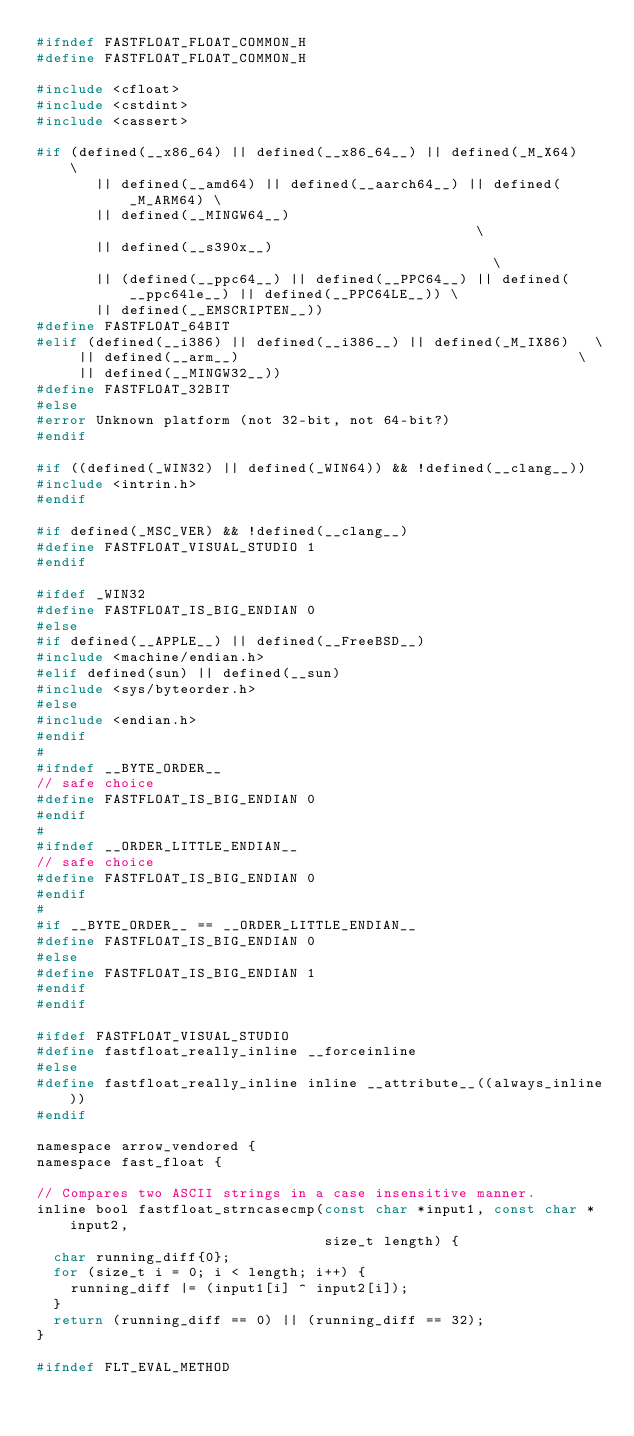<code> <loc_0><loc_0><loc_500><loc_500><_C_>#ifndef FASTFLOAT_FLOAT_COMMON_H
#define FASTFLOAT_FLOAT_COMMON_H

#include <cfloat>
#include <cstdint>
#include <cassert>

#if (defined(__x86_64) || defined(__x86_64__) || defined(_M_X64)   \
       || defined(__amd64) || defined(__aarch64__) || defined(_M_ARM64) \
       || defined(__MINGW64__)                                          \
       || defined(__s390x__)                                            \
       || (defined(__ppc64__) || defined(__PPC64__) || defined(__ppc64le__) || defined(__PPC64LE__)) \
       || defined(__EMSCRIPTEN__))
#define FASTFLOAT_64BIT
#elif (defined(__i386) || defined(__i386__) || defined(_M_IX86)   \
     || defined(__arm__)                                        \
     || defined(__MINGW32__))
#define FASTFLOAT_32BIT
#else
#error Unknown platform (not 32-bit, not 64-bit?)
#endif

#if ((defined(_WIN32) || defined(_WIN64)) && !defined(__clang__))
#include <intrin.h>
#endif

#if defined(_MSC_VER) && !defined(__clang__)
#define FASTFLOAT_VISUAL_STUDIO 1
#endif

#ifdef _WIN32
#define FASTFLOAT_IS_BIG_ENDIAN 0
#else
#if defined(__APPLE__) || defined(__FreeBSD__)
#include <machine/endian.h>
#elif defined(sun) || defined(__sun)
#include <sys/byteorder.h>
#else
#include <endian.h>
#endif
#
#ifndef __BYTE_ORDER__
// safe choice
#define FASTFLOAT_IS_BIG_ENDIAN 0
#endif
#
#ifndef __ORDER_LITTLE_ENDIAN__
// safe choice
#define FASTFLOAT_IS_BIG_ENDIAN 0
#endif
#
#if __BYTE_ORDER__ == __ORDER_LITTLE_ENDIAN__
#define FASTFLOAT_IS_BIG_ENDIAN 0
#else
#define FASTFLOAT_IS_BIG_ENDIAN 1
#endif
#endif

#ifdef FASTFLOAT_VISUAL_STUDIO
#define fastfloat_really_inline __forceinline
#else
#define fastfloat_really_inline inline __attribute__((always_inline))
#endif

namespace arrow_vendored {
namespace fast_float {

// Compares two ASCII strings in a case insensitive manner.
inline bool fastfloat_strncasecmp(const char *input1, const char *input2,
                                  size_t length) {
  char running_diff{0};
  for (size_t i = 0; i < length; i++) {
    running_diff |= (input1[i] ^ input2[i]);
  }
  return (running_diff == 0) || (running_diff == 32);
}

#ifndef FLT_EVAL_METHOD</code> 